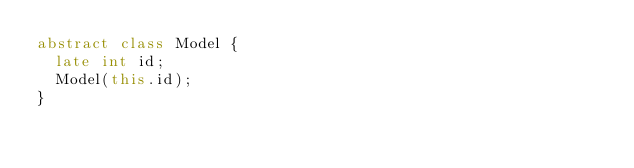Convert code to text. <code><loc_0><loc_0><loc_500><loc_500><_Dart_>abstract class Model {
  late int id;
  Model(this.id);
}</code> 